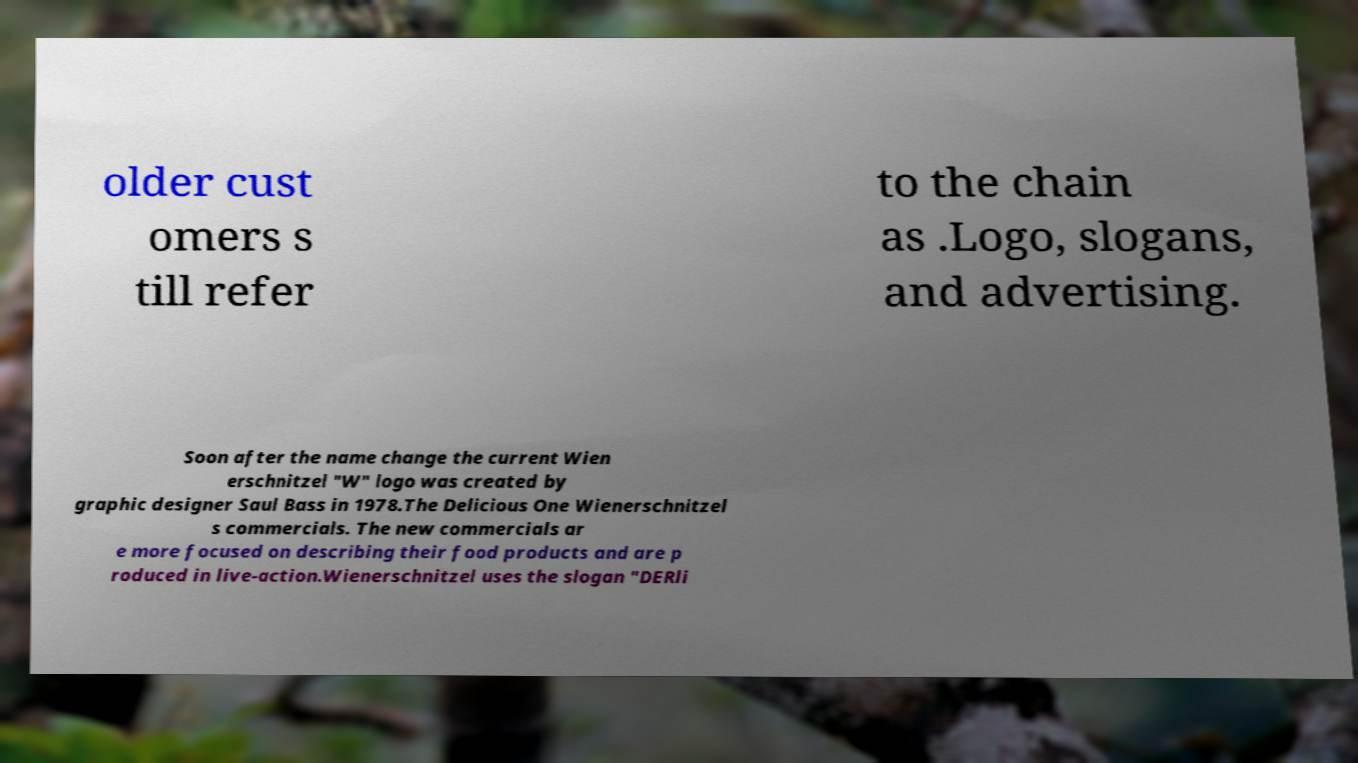For documentation purposes, I need the text within this image transcribed. Could you provide that? older cust omers s till refer to the chain as .Logo, slogans, and advertising. Soon after the name change the current Wien erschnitzel "W" logo was created by graphic designer Saul Bass in 1978.The Delicious One Wienerschnitzel s commercials. The new commercials ar e more focused on describing their food products and are p roduced in live-action.Wienerschnitzel uses the slogan "DERli 